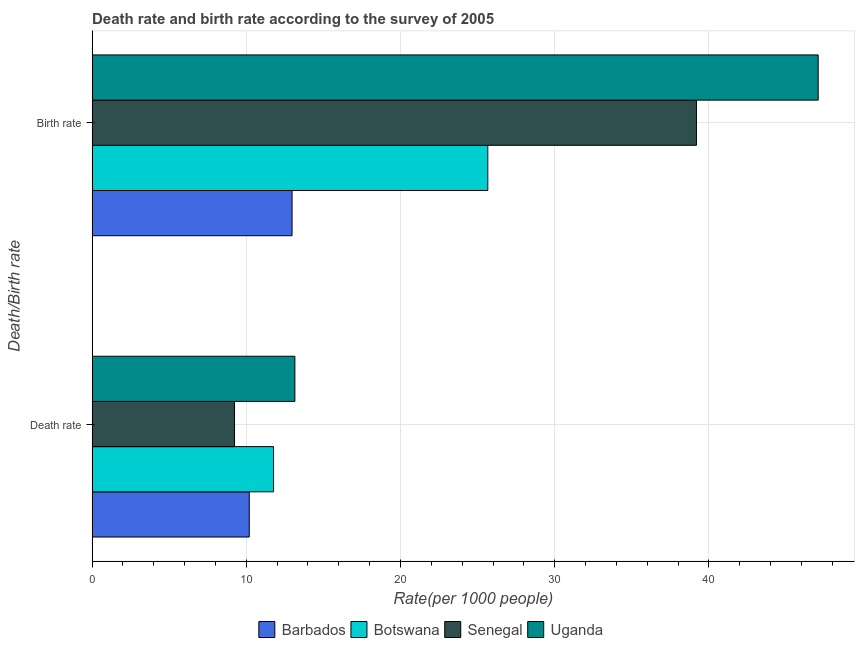How many groups of bars are there?
Your answer should be compact. 2. Are the number of bars per tick equal to the number of legend labels?
Provide a short and direct response. Yes. Are the number of bars on each tick of the Y-axis equal?
Make the answer very short. Yes. How many bars are there on the 2nd tick from the top?
Keep it short and to the point. 4. What is the label of the 1st group of bars from the top?
Provide a short and direct response. Birth rate. What is the death rate in Botswana?
Keep it short and to the point. 11.77. Across all countries, what is the maximum birth rate?
Offer a very short reply. 47.09. Across all countries, what is the minimum death rate?
Your answer should be very brief. 9.24. In which country was the birth rate maximum?
Offer a very short reply. Uganda. In which country was the death rate minimum?
Offer a terse response. Senegal. What is the total birth rate in the graph?
Give a very brief answer. 124.91. What is the difference between the death rate in Uganda and that in Botswana?
Provide a short and direct response. 1.38. What is the difference between the birth rate in Barbados and the death rate in Botswana?
Offer a terse response. 1.2. What is the average death rate per country?
Ensure brevity in your answer.  11.09. What is the difference between the death rate and birth rate in Barbados?
Keep it short and to the point. -2.77. What is the ratio of the birth rate in Uganda to that in Senegal?
Provide a short and direct response. 1.2. Is the death rate in Botswana less than that in Barbados?
Your answer should be very brief. No. What does the 3rd bar from the top in Birth rate represents?
Offer a very short reply. Botswana. What does the 3rd bar from the bottom in Birth rate represents?
Your response must be concise. Senegal. How many bars are there?
Provide a succinct answer. 8. Are all the bars in the graph horizontal?
Give a very brief answer. Yes. Are the values on the major ticks of X-axis written in scientific E-notation?
Ensure brevity in your answer.  No. Does the graph contain any zero values?
Keep it short and to the point. No. Does the graph contain grids?
Offer a very short reply. Yes. Where does the legend appear in the graph?
Your answer should be compact. Bottom center. How are the legend labels stacked?
Make the answer very short. Horizontal. What is the title of the graph?
Provide a succinct answer. Death rate and birth rate according to the survey of 2005. Does "Fiji" appear as one of the legend labels in the graph?
Offer a terse response. No. What is the label or title of the X-axis?
Offer a very short reply. Rate(per 1000 people). What is the label or title of the Y-axis?
Your response must be concise. Death/Birth rate. What is the Rate(per 1000 people) in Barbados in Death rate?
Keep it short and to the point. 10.19. What is the Rate(per 1000 people) of Botswana in Death rate?
Your answer should be compact. 11.77. What is the Rate(per 1000 people) in Senegal in Death rate?
Ensure brevity in your answer.  9.24. What is the Rate(per 1000 people) in Uganda in Death rate?
Offer a terse response. 13.15. What is the Rate(per 1000 people) of Barbados in Birth rate?
Give a very brief answer. 12.97. What is the Rate(per 1000 people) in Botswana in Birth rate?
Ensure brevity in your answer.  25.66. What is the Rate(per 1000 people) of Senegal in Birth rate?
Offer a terse response. 39.19. What is the Rate(per 1000 people) of Uganda in Birth rate?
Your answer should be very brief. 47.09. Across all Death/Birth rate, what is the maximum Rate(per 1000 people) in Barbados?
Your answer should be compact. 12.97. Across all Death/Birth rate, what is the maximum Rate(per 1000 people) in Botswana?
Ensure brevity in your answer.  25.66. Across all Death/Birth rate, what is the maximum Rate(per 1000 people) of Senegal?
Your answer should be compact. 39.19. Across all Death/Birth rate, what is the maximum Rate(per 1000 people) in Uganda?
Provide a succinct answer. 47.09. Across all Death/Birth rate, what is the minimum Rate(per 1000 people) in Barbados?
Provide a short and direct response. 10.19. Across all Death/Birth rate, what is the minimum Rate(per 1000 people) in Botswana?
Your answer should be compact. 11.77. Across all Death/Birth rate, what is the minimum Rate(per 1000 people) in Senegal?
Your answer should be very brief. 9.24. Across all Death/Birth rate, what is the minimum Rate(per 1000 people) of Uganda?
Provide a succinct answer. 13.15. What is the total Rate(per 1000 people) in Barbados in the graph?
Give a very brief answer. 23.16. What is the total Rate(per 1000 people) in Botswana in the graph?
Your answer should be compact. 37.43. What is the total Rate(per 1000 people) in Senegal in the graph?
Your answer should be compact. 48.43. What is the total Rate(per 1000 people) of Uganda in the graph?
Your answer should be very brief. 60.24. What is the difference between the Rate(per 1000 people) in Barbados in Death rate and that in Birth rate?
Offer a terse response. -2.77. What is the difference between the Rate(per 1000 people) of Botswana in Death rate and that in Birth rate?
Your answer should be compact. -13.89. What is the difference between the Rate(per 1000 people) of Senegal in Death rate and that in Birth rate?
Provide a short and direct response. -29.96. What is the difference between the Rate(per 1000 people) of Uganda in Death rate and that in Birth rate?
Offer a very short reply. -33.94. What is the difference between the Rate(per 1000 people) of Barbados in Death rate and the Rate(per 1000 people) of Botswana in Birth rate?
Ensure brevity in your answer.  -15.47. What is the difference between the Rate(per 1000 people) in Barbados in Death rate and the Rate(per 1000 people) in Uganda in Birth rate?
Offer a terse response. -36.9. What is the difference between the Rate(per 1000 people) in Botswana in Death rate and the Rate(per 1000 people) in Senegal in Birth rate?
Ensure brevity in your answer.  -27.43. What is the difference between the Rate(per 1000 people) of Botswana in Death rate and the Rate(per 1000 people) of Uganda in Birth rate?
Provide a succinct answer. -35.32. What is the difference between the Rate(per 1000 people) of Senegal in Death rate and the Rate(per 1000 people) of Uganda in Birth rate?
Give a very brief answer. -37.85. What is the average Rate(per 1000 people) in Barbados per Death/Birth rate?
Keep it short and to the point. 11.58. What is the average Rate(per 1000 people) in Botswana per Death/Birth rate?
Offer a very short reply. 18.71. What is the average Rate(per 1000 people) in Senegal per Death/Birth rate?
Keep it short and to the point. 24.21. What is the average Rate(per 1000 people) of Uganda per Death/Birth rate?
Offer a terse response. 30.12. What is the difference between the Rate(per 1000 people) of Barbados and Rate(per 1000 people) of Botswana in Death rate?
Make the answer very short. -1.57. What is the difference between the Rate(per 1000 people) in Barbados and Rate(per 1000 people) in Senegal in Death rate?
Give a very brief answer. 0.96. What is the difference between the Rate(per 1000 people) of Barbados and Rate(per 1000 people) of Uganda in Death rate?
Offer a very short reply. -2.96. What is the difference between the Rate(per 1000 people) of Botswana and Rate(per 1000 people) of Senegal in Death rate?
Offer a terse response. 2.53. What is the difference between the Rate(per 1000 people) of Botswana and Rate(per 1000 people) of Uganda in Death rate?
Your response must be concise. -1.38. What is the difference between the Rate(per 1000 people) in Senegal and Rate(per 1000 people) in Uganda in Death rate?
Provide a succinct answer. -3.91. What is the difference between the Rate(per 1000 people) in Barbados and Rate(per 1000 people) in Botswana in Birth rate?
Your answer should be very brief. -12.7. What is the difference between the Rate(per 1000 people) of Barbados and Rate(per 1000 people) of Senegal in Birth rate?
Offer a terse response. -26.23. What is the difference between the Rate(per 1000 people) of Barbados and Rate(per 1000 people) of Uganda in Birth rate?
Your response must be concise. -34.12. What is the difference between the Rate(per 1000 people) in Botswana and Rate(per 1000 people) in Senegal in Birth rate?
Your response must be concise. -13.53. What is the difference between the Rate(per 1000 people) of Botswana and Rate(per 1000 people) of Uganda in Birth rate?
Keep it short and to the point. -21.43. What is the difference between the Rate(per 1000 people) in Senegal and Rate(per 1000 people) in Uganda in Birth rate?
Give a very brief answer. -7.89. What is the ratio of the Rate(per 1000 people) in Barbados in Death rate to that in Birth rate?
Offer a very short reply. 0.79. What is the ratio of the Rate(per 1000 people) in Botswana in Death rate to that in Birth rate?
Your response must be concise. 0.46. What is the ratio of the Rate(per 1000 people) of Senegal in Death rate to that in Birth rate?
Make the answer very short. 0.24. What is the ratio of the Rate(per 1000 people) in Uganda in Death rate to that in Birth rate?
Ensure brevity in your answer.  0.28. What is the difference between the highest and the second highest Rate(per 1000 people) in Barbados?
Provide a succinct answer. 2.77. What is the difference between the highest and the second highest Rate(per 1000 people) in Botswana?
Provide a short and direct response. 13.89. What is the difference between the highest and the second highest Rate(per 1000 people) in Senegal?
Your answer should be very brief. 29.96. What is the difference between the highest and the second highest Rate(per 1000 people) of Uganda?
Provide a succinct answer. 33.94. What is the difference between the highest and the lowest Rate(per 1000 people) of Barbados?
Offer a very short reply. 2.77. What is the difference between the highest and the lowest Rate(per 1000 people) of Botswana?
Ensure brevity in your answer.  13.89. What is the difference between the highest and the lowest Rate(per 1000 people) of Senegal?
Make the answer very short. 29.96. What is the difference between the highest and the lowest Rate(per 1000 people) of Uganda?
Ensure brevity in your answer.  33.94. 